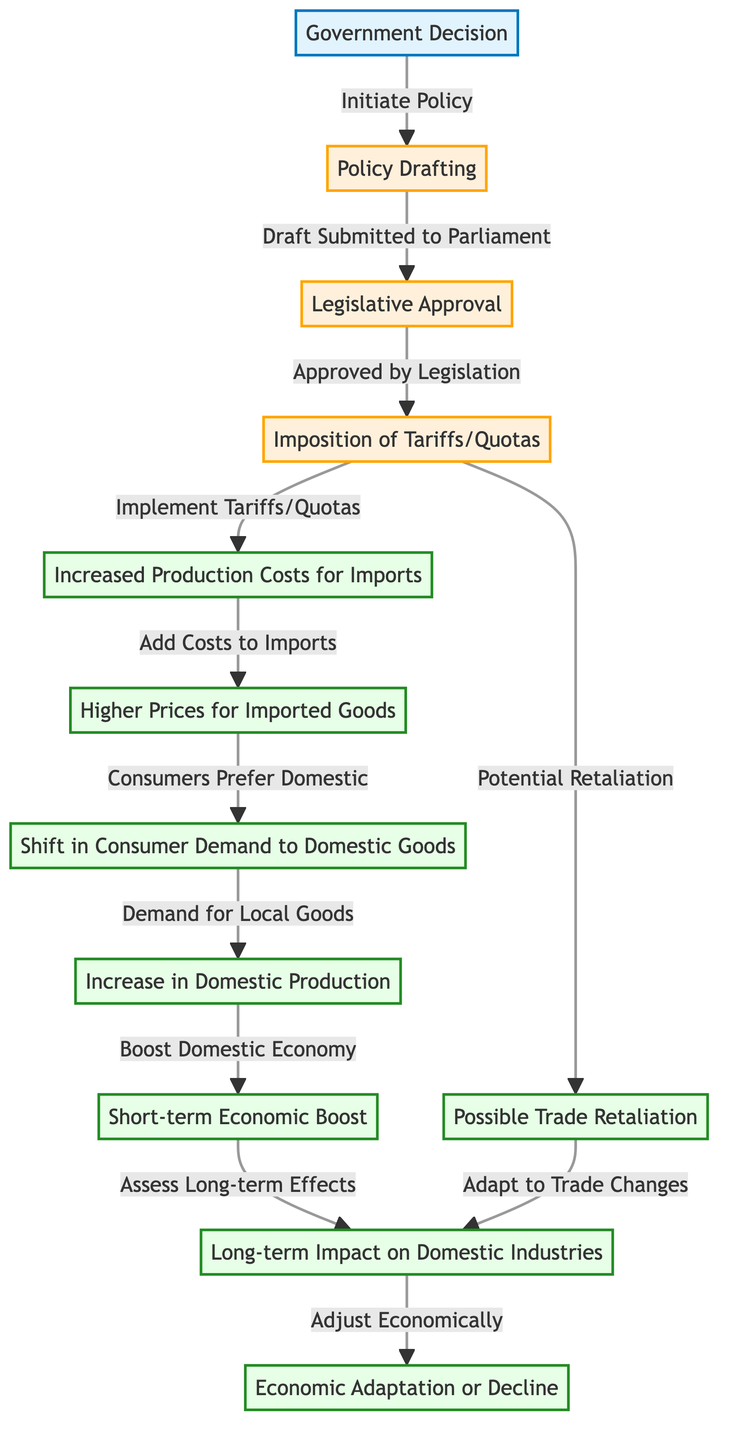What is the first step in the process? The first step is labeled "Government Decision." Following the flow from the top of the diagram, it clearly indicates that this is the initiating action for the policy-making process.
Answer: Government Decision How many main steps are there in the described process? By counting the numbered nodes or steps in the flowchart, there are a total of 12 main steps in the process and effects of implementing protectionist policies.
Answer: 12 What happens immediately after the "Imposition of Tariffs/Quotas"? After this step, the flowchart indicates that there is an "Increased Production Costs for Imports," which is the next action that follows the imposition. This shows a direct consequence of the policy implementation.
Answer: Increased Production Costs for Imports Which impact follows the "Short-term Economic Boost"? Following the "Short-term Economic Boost," the flowchart shows that the next step is "Assess Long-term Effects," indicating the transition from immediate results to evaluating longer-term consequences.
Answer: Assess Long-term Effects What is a possible consequence of implementing tariffs/quota according to the diagram? The diagram depicts "Possible Trade Retaliation" as a direct response or consequence that could occur after imposing tariffs or quotas, reflecting the potential for reciprocal actions by other countries.
Answer: Possible Trade Retaliation Which node refers to the adjustment phase after assessing long-term impacts? According to the flow of the diagram, the node titled "Economic Adaptation or Decline" refers to this adjustment phase, following the long-term effects assessment.
Answer: Economic Adaptation or Decline What is indicated by the arrow linking "Consumers Prefer Domestic" to "Demand for Local Goods"? This arrow signifies a direct causal relationship showing that an increase in consumer preference for domestic products translates into a higher demand for these local goods, illustrating the shift in consumer behavior.
Answer: Demand for Local Goods Which node is emphasized in bold indicating its significance in the flow? The node "Legislative Approval" is bolded in the diagram, which signifies its importance in the protectionist policy process as a critical step that must occur after policy drafting.
Answer: Legislative Approval What two outcomes can follow after "Possible Trade Retaliation"? The outcomes that can follow are "Adapt to Trade Changes" and "Long-term Impact on Domestic Industries," both of which indicate subsequent effects stemming from retaliatory actions.
Answer: Adapt to Trade Changes, Long-term Impact on Domestic Industries 